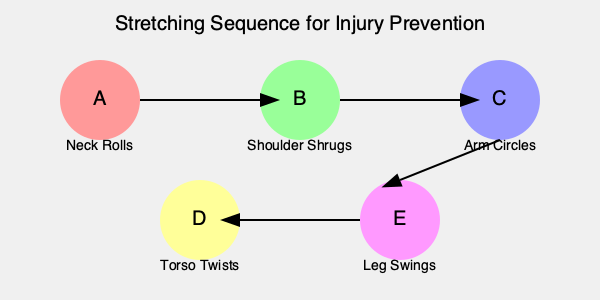Based on the principle of progressing from top to bottom and from less intense to more intense movements, what is the correct sequence of stretching positions for injury prevention? To determine the proper sequence of stretching positions for injury prevention, we need to consider the principle of progressing from top to bottom of the body and from less intense to more intense movements. Let's analyze each position:

1. Position A (Neck Rolls): This targets the topmost part of the body and is a gentle, less intense movement.
2. Position B (Shoulder Shrugs): This focuses on the upper body and is still relatively gentle.
3. Position C (Arm Circles): This involves the upper body but is more dynamic than shoulder shrugs.
4. Position D (Torso Twists): This targets the core and is more intense than the previous movements.
5. Position E (Leg Swings): This focuses on the lower body and is the most dynamic movement.

Following the principle of top-to-bottom progression:
- We start with A (Neck Rolls) as it's the topmost part of the body.
- Then we move to B (Shoulder Shrugs) as it's the next area going down.
- C (Arm Circles) follows as it's still upper body but more dynamic.
- D (Torso Twists) comes next as we move to the core.
- Finally, E (Leg Swings) as it targets the lower body and is the most dynamic.

This sequence ensures a gradual warm-up of the body from top to bottom while progressively increasing the intensity of movements.
Answer: A-B-C-D-E 